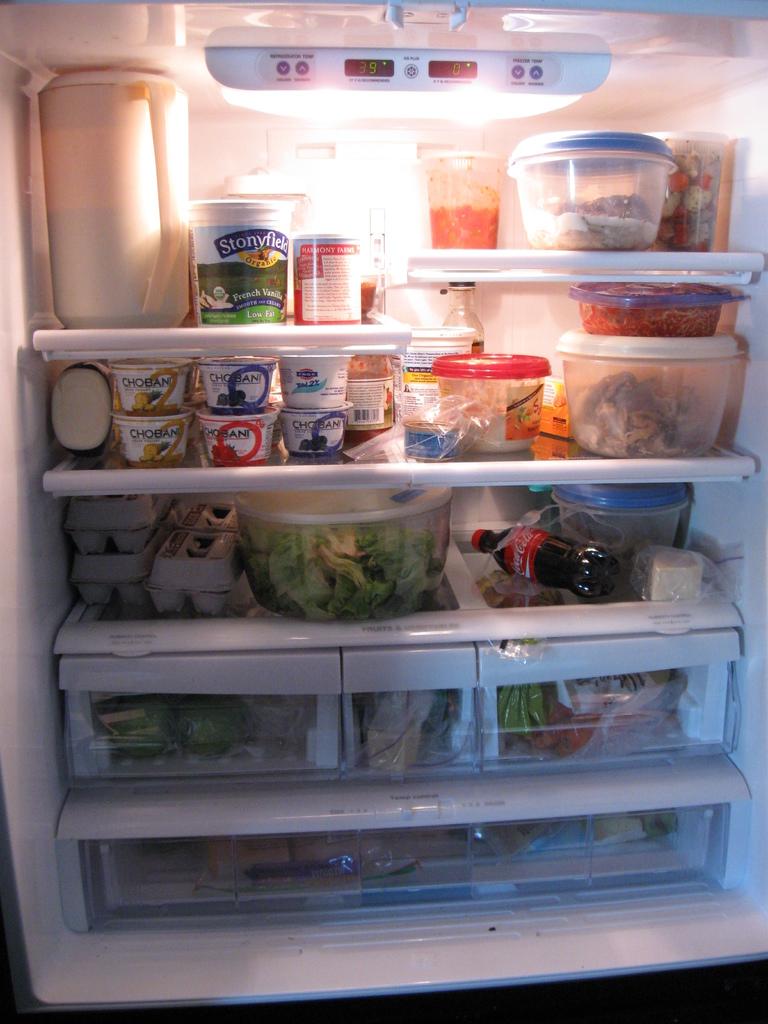What kind of yogurt is in the fridge?
Keep it short and to the point. Chobani. Does the fridge have a coke soda in it?
Offer a terse response. Yes. 